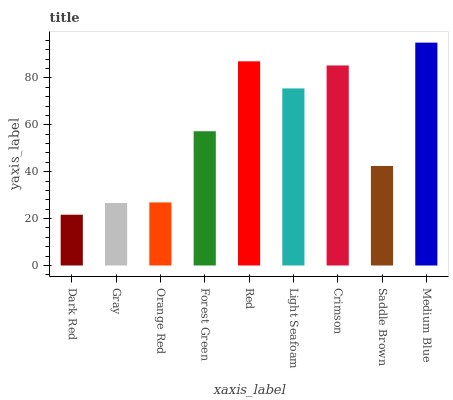Is Dark Red the minimum?
Answer yes or no. Yes. Is Medium Blue the maximum?
Answer yes or no. Yes. Is Gray the minimum?
Answer yes or no. No. Is Gray the maximum?
Answer yes or no. No. Is Gray greater than Dark Red?
Answer yes or no. Yes. Is Dark Red less than Gray?
Answer yes or no. Yes. Is Dark Red greater than Gray?
Answer yes or no. No. Is Gray less than Dark Red?
Answer yes or no. No. Is Forest Green the high median?
Answer yes or no. Yes. Is Forest Green the low median?
Answer yes or no. Yes. Is Gray the high median?
Answer yes or no. No. Is Medium Blue the low median?
Answer yes or no. No. 